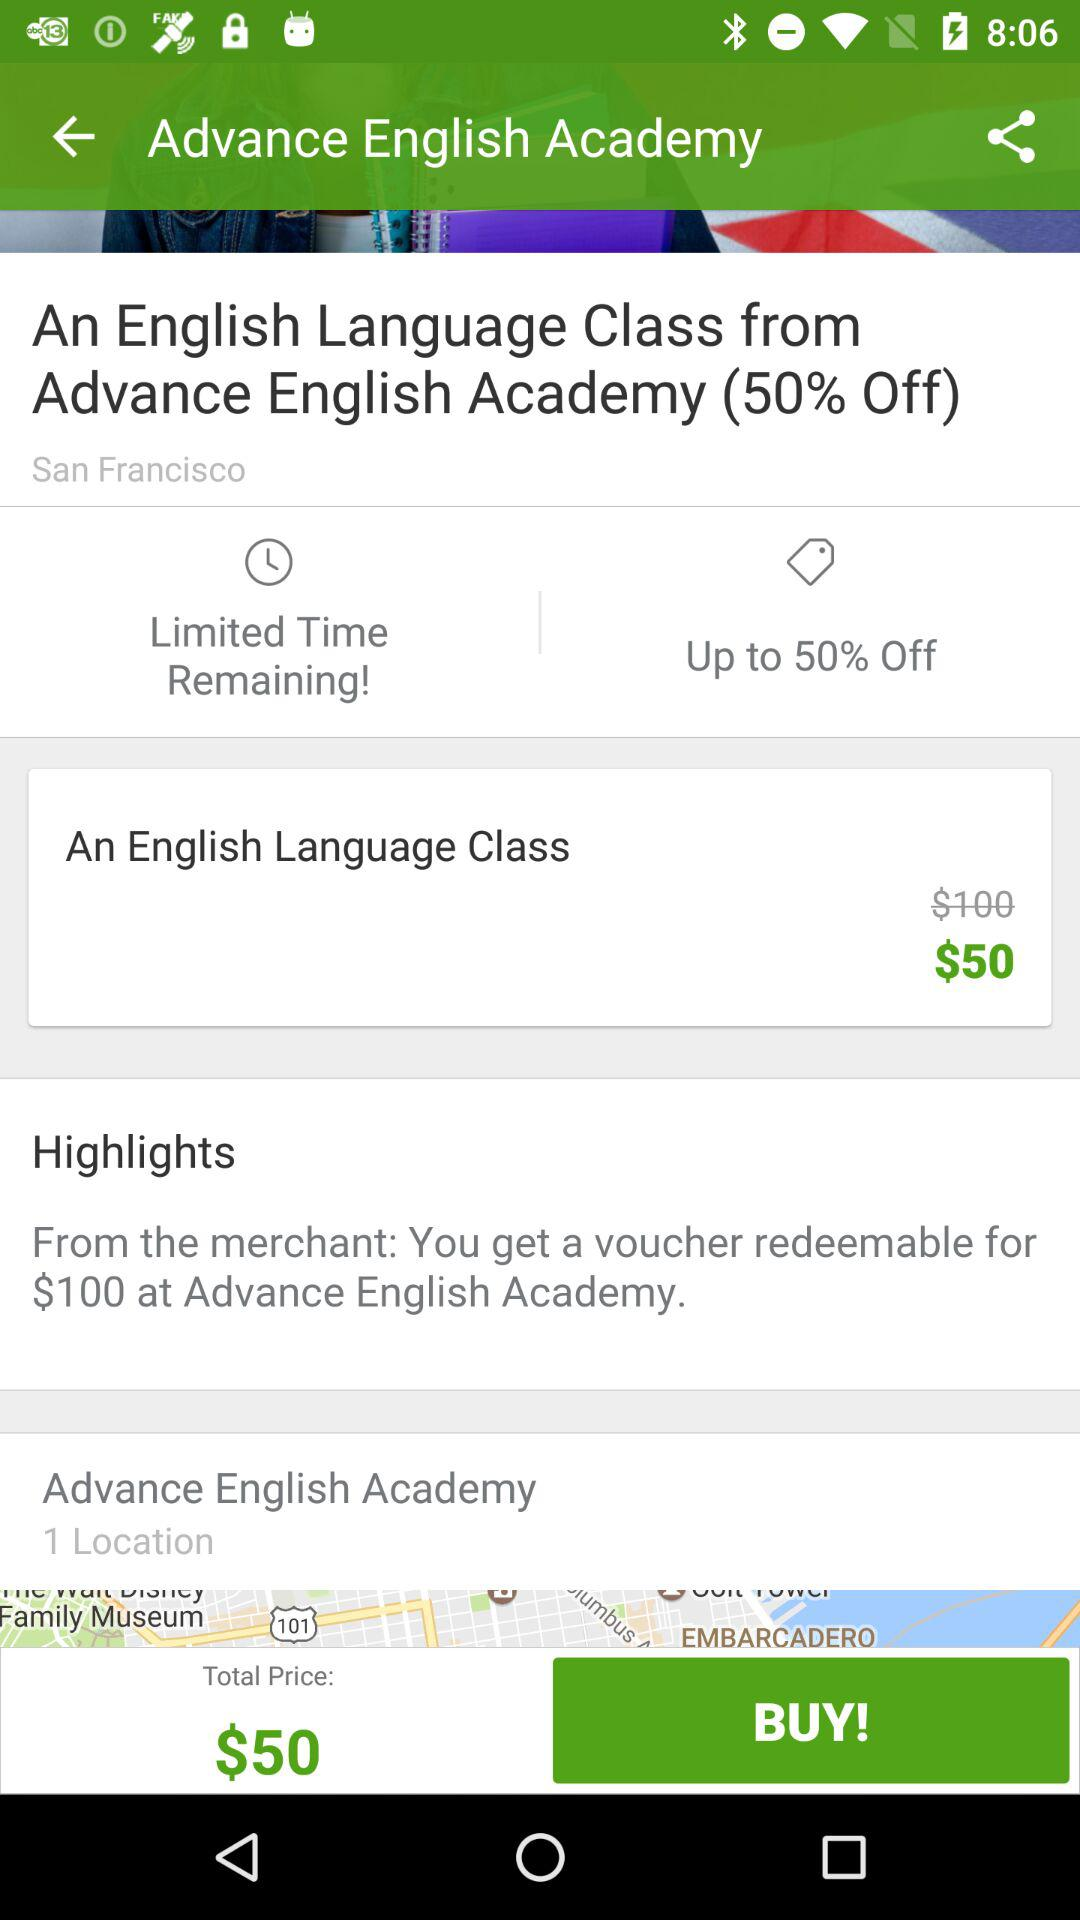How many dollar redeemable vouchers do you get from the merchant? You get $100 redeemable voucher. 